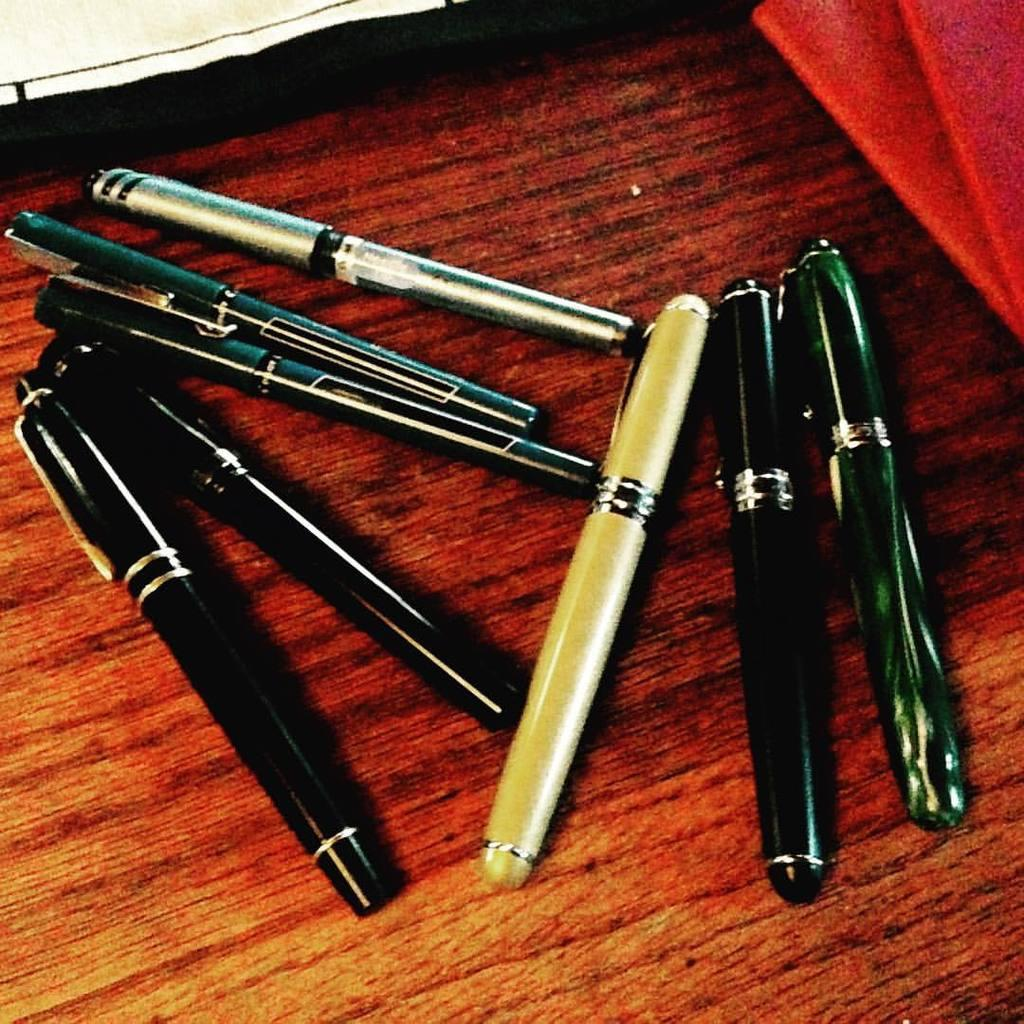What objects are visible in the image? There are pens in the image. Where are the pens located? The pens are on a wooden platform. Are there any straws being used in a protest by ants in the image? There is no mention of straws, protests, or ants in the image. The image only features pens on a wooden platform. 